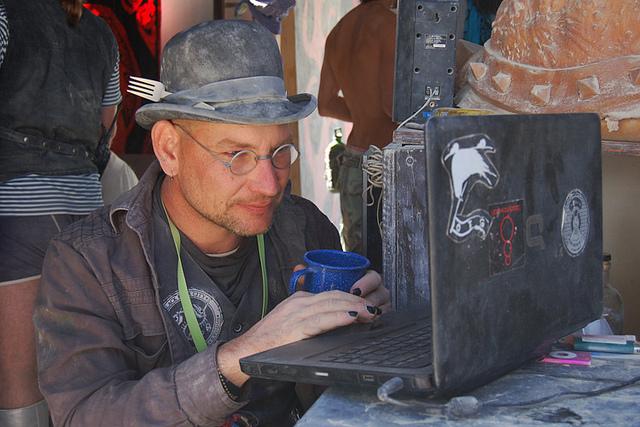Where is the shirtless person?
Answer briefly. Background. What color is this mans nails painted?
Write a very short answer. Black. What color is the hat?
Concise answer only. Gray. 